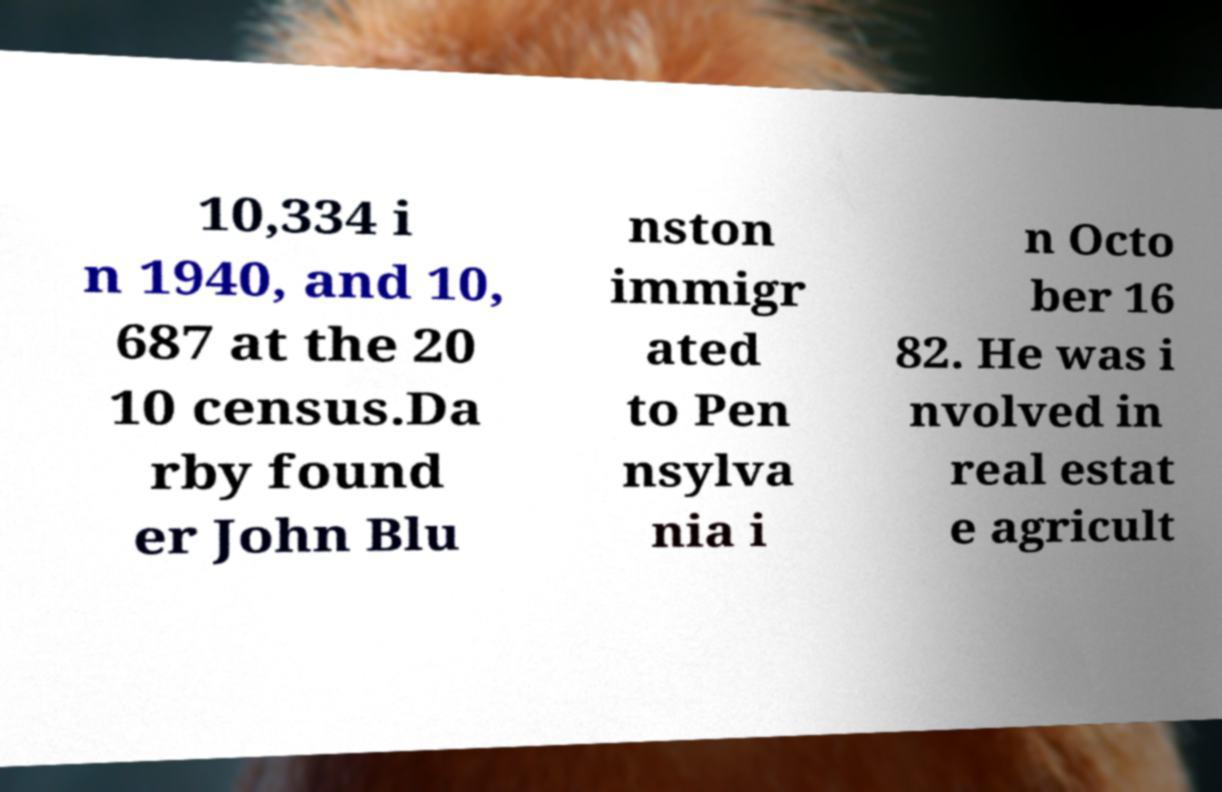For documentation purposes, I need the text within this image transcribed. Could you provide that? 10,334 i n 1940, and 10, 687 at the 20 10 census.Da rby found er John Blu nston immigr ated to Pen nsylva nia i n Octo ber 16 82. He was i nvolved in real estat e agricult 